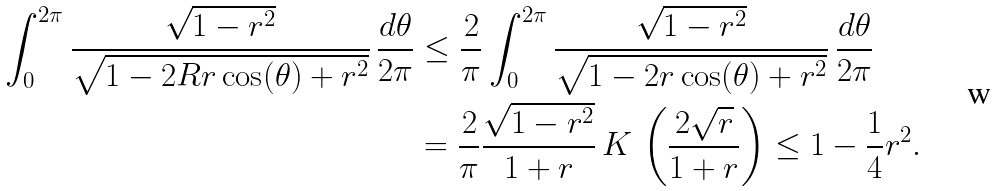Convert formula to latex. <formula><loc_0><loc_0><loc_500><loc_500>\int _ { 0 } ^ { 2 \pi } \frac { \sqrt { 1 - r ^ { 2 } } } { \sqrt { 1 - 2 R r \cos ( \theta ) + r ^ { 2 } } } \, \frac { d \theta } { 2 \pi } & \leq \frac { 2 } { \pi } \int _ { 0 } ^ { 2 \pi } \frac { \sqrt { 1 - r ^ { 2 } } } { \sqrt { 1 - 2 r \cos ( \theta ) + r ^ { 2 } } } \, \frac { d \theta } { 2 \pi } \\ & = \frac { 2 } { \pi } \frac { \sqrt { 1 - r ^ { 2 } } } { 1 + r } \, K \, \left ( \frac { 2 \sqrt { r } } { 1 + r } \right ) \leq 1 - \frac { 1 } { 4 } r ^ { 2 } .</formula> 